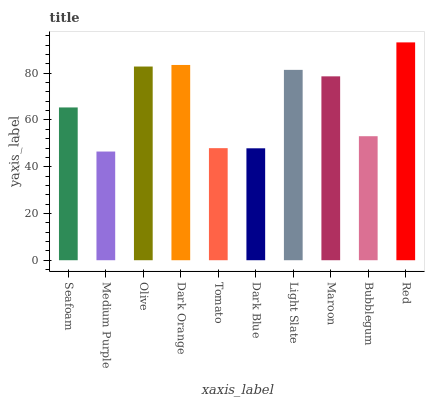Is Medium Purple the minimum?
Answer yes or no. Yes. Is Red the maximum?
Answer yes or no. Yes. Is Olive the minimum?
Answer yes or no. No. Is Olive the maximum?
Answer yes or no. No. Is Olive greater than Medium Purple?
Answer yes or no. Yes. Is Medium Purple less than Olive?
Answer yes or no. Yes. Is Medium Purple greater than Olive?
Answer yes or no. No. Is Olive less than Medium Purple?
Answer yes or no. No. Is Maroon the high median?
Answer yes or no. Yes. Is Seafoam the low median?
Answer yes or no. Yes. Is Dark Orange the high median?
Answer yes or no. No. Is Bubblegum the low median?
Answer yes or no. No. 